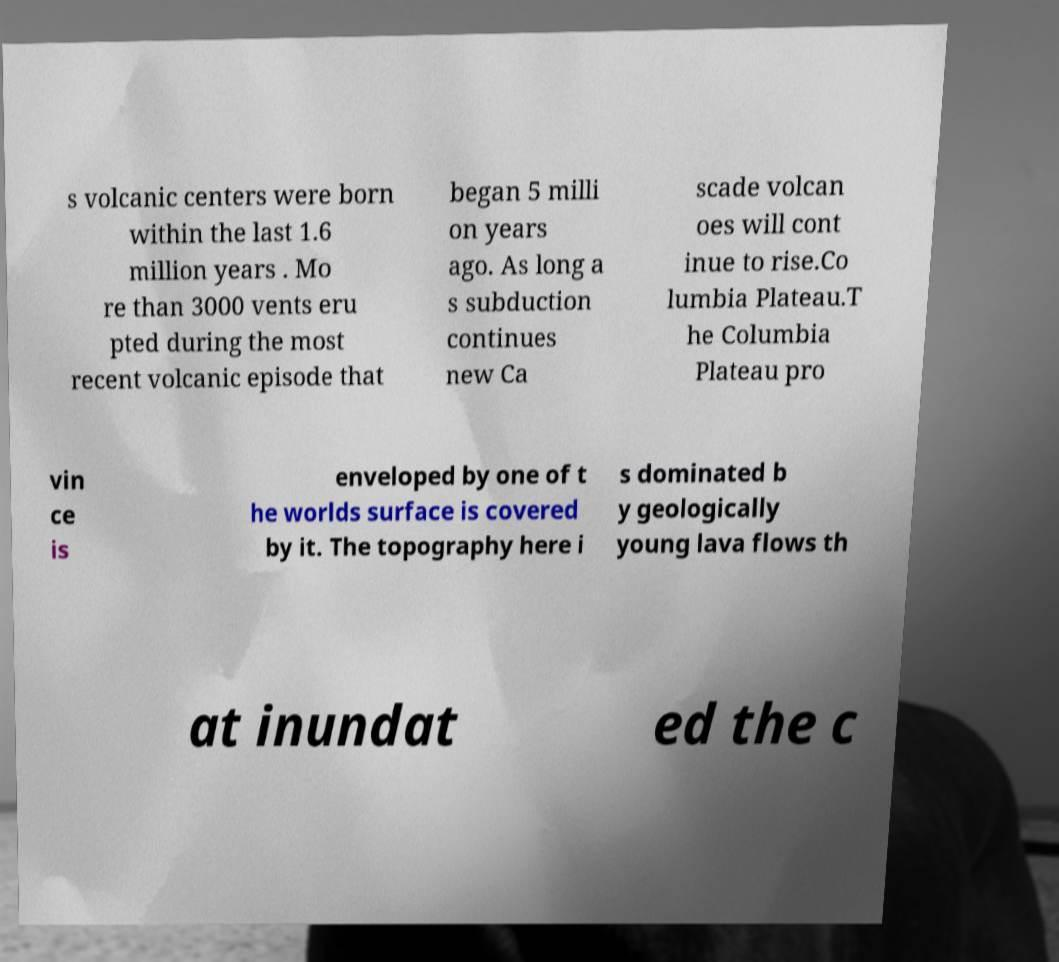For documentation purposes, I need the text within this image transcribed. Could you provide that? s volcanic centers were born within the last 1.6 million years . Mo re than 3000 vents eru pted during the most recent volcanic episode that began 5 milli on years ago. As long a s subduction continues new Ca scade volcan oes will cont inue to rise.Co lumbia Plateau.T he Columbia Plateau pro vin ce is enveloped by one of t he worlds surface is covered by it. The topography here i s dominated b y geologically young lava flows th at inundat ed the c 